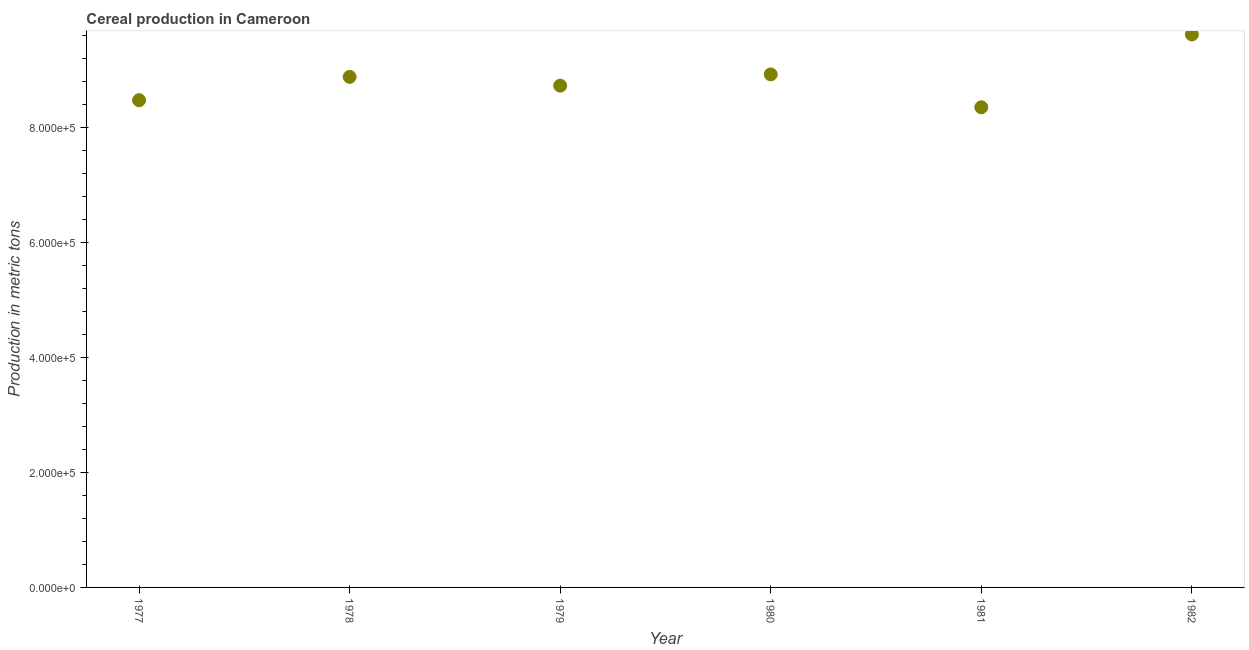What is the cereal production in 1981?
Your answer should be very brief. 8.35e+05. Across all years, what is the maximum cereal production?
Your answer should be compact. 9.61e+05. Across all years, what is the minimum cereal production?
Make the answer very short. 8.35e+05. In which year was the cereal production maximum?
Give a very brief answer. 1982. What is the sum of the cereal production?
Your response must be concise. 5.29e+06. What is the difference between the cereal production in 1978 and 1982?
Your answer should be compact. -7.38e+04. What is the average cereal production per year?
Offer a terse response. 8.82e+05. What is the median cereal production?
Your answer should be compact. 8.80e+05. In how many years, is the cereal production greater than 760000 metric tons?
Make the answer very short. 6. Do a majority of the years between 1978 and 1982 (inclusive) have cereal production greater than 600000 metric tons?
Your answer should be compact. Yes. What is the ratio of the cereal production in 1979 to that in 1980?
Provide a succinct answer. 0.98. What is the difference between the highest and the second highest cereal production?
Ensure brevity in your answer.  6.94e+04. What is the difference between the highest and the lowest cereal production?
Provide a succinct answer. 1.27e+05. Does the cereal production monotonically increase over the years?
Your answer should be very brief. No. How many dotlines are there?
Make the answer very short. 1. What is the difference between two consecutive major ticks on the Y-axis?
Offer a very short reply. 2.00e+05. Are the values on the major ticks of Y-axis written in scientific E-notation?
Give a very brief answer. Yes. Does the graph contain any zero values?
Ensure brevity in your answer.  No. Does the graph contain grids?
Offer a very short reply. No. What is the title of the graph?
Offer a terse response. Cereal production in Cameroon. What is the label or title of the Y-axis?
Make the answer very short. Production in metric tons. What is the Production in metric tons in 1977?
Your response must be concise. 8.47e+05. What is the Production in metric tons in 1978?
Your answer should be very brief. 8.87e+05. What is the Production in metric tons in 1979?
Your answer should be compact. 8.72e+05. What is the Production in metric tons in 1980?
Offer a very short reply. 8.92e+05. What is the Production in metric tons in 1981?
Your answer should be compact. 8.35e+05. What is the Production in metric tons in 1982?
Your answer should be very brief. 9.61e+05. What is the difference between the Production in metric tons in 1977 and 1978?
Your response must be concise. -4.05e+04. What is the difference between the Production in metric tons in 1977 and 1979?
Your answer should be compact. -2.53e+04. What is the difference between the Production in metric tons in 1977 and 1980?
Ensure brevity in your answer.  -4.48e+04. What is the difference between the Production in metric tons in 1977 and 1981?
Make the answer very short. 1.23e+04. What is the difference between the Production in metric tons in 1977 and 1982?
Your answer should be compact. -1.14e+05. What is the difference between the Production in metric tons in 1978 and 1979?
Ensure brevity in your answer.  1.53e+04. What is the difference between the Production in metric tons in 1978 and 1980?
Offer a terse response. -4325. What is the difference between the Production in metric tons in 1978 and 1981?
Offer a terse response. 5.28e+04. What is the difference between the Production in metric tons in 1978 and 1982?
Offer a very short reply. -7.38e+04. What is the difference between the Production in metric tons in 1979 and 1980?
Give a very brief answer. -1.96e+04. What is the difference between the Production in metric tons in 1979 and 1981?
Provide a short and direct response. 3.76e+04. What is the difference between the Production in metric tons in 1979 and 1982?
Offer a very short reply. -8.90e+04. What is the difference between the Production in metric tons in 1980 and 1981?
Your answer should be compact. 5.72e+04. What is the difference between the Production in metric tons in 1980 and 1982?
Your answer should be very brief. -6.94e+04. What is the difference between the Production in metric tons in 1981 and 1982?
Ensure brevity in your answer.  -1.27e+05. What is the ratio of the Production in metric tons in 1977 to that in 1978?
Offer a very short reply. 0.95. What is the ratio of the Production in metric tons in 1977 to that in 1979?
Your answer should be compact. 0.97. What is the ratio of the Production in metric tons in 1977 to that in 1980?
Keep it short and to the point. 0.95. What is the ratio of the Production in metric tons in 1977 to that in 1982?
Give a very brief answer. 0.88. What is the ratio of the Production in metric tons in 1978 to that in 1981?
Ensure brevity in your answer.  1.06. What is the ratio of the Production in metric tons in 1978 to that in 1982?
Offer a very short reply. 0.92. What is the ratio of the Production in metric tons in 1979 to that in 1980?
Ensure brevity in your answer.  0.98. What is the ratio of the Production in metric tons in 1979 to that in 1981?
Make the answer very short. 1.04. What is the ratio of the Production in metric tons in 1979 to that in 1982?
Offer a very short reply. 0.91. What is the ratio of the Production in metric tons in 1980 to that in 1981?
Your answer should be very brief. 1.07. What is the ratio of the Production in metric tons in 1980 to that in 1982?
Offer a very short reply. 0.93. What is the ratio of the Production in metric tons in 1981 to that in 1982?
Your response must be concise. 0.87. 